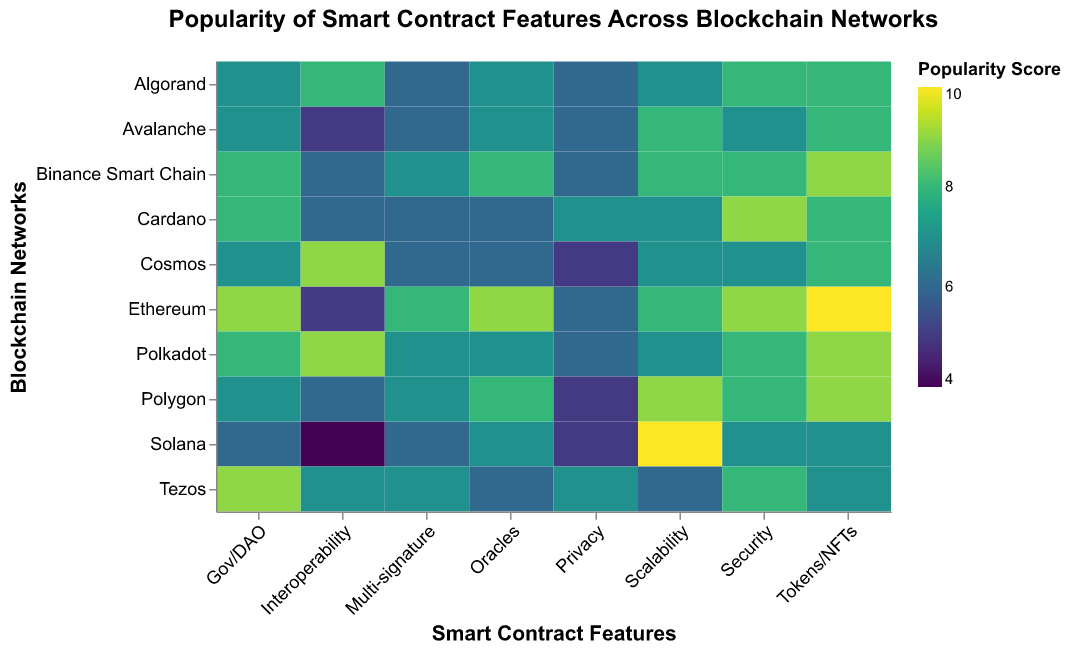What's the title of the figure? The title of the figure is prominently located at the top, which describes the general content of the visualization.
Answer: Popularity of Smart Contract Features Across Blockchain Networks Which blockchain network scores the highest for Scalability? Look at the color scale for Scalability. The darkest/vibrant color corresponds to the highest score.
Answer: Solana What is the average popularity score for Privacy across all blockchain networks? Extract the scores for Privacy from all networks: Ethereum (6), Binance Smart Chain (6), Polkadot (6), Solana (5), Cardano (7), Avalanche (6), Tezos (7), Polygon (5), Algorand (6), Cosmos (5). Sum these scores: 6+6+6+5+7+6+7+5+6+5 = 59. Divide by the number of networks (10): 59/10 = 5.9
Answer: 5.9 Which feature is the least popular for Solana? Identify the feature with the lowest color intensity (pale color) for Solana.
Answer: Interoperability Between Ethereum and Binance Smart Chain, which network scores higher on Security and by how much? Look at the rows for Ethereum and Binance Smart Chain under the Security column. Note the scores: Ethereum (9) and Binance Smart Chain (8). Subtract the smaller score from the larger one: 9 - 8 = 1
Answer: Ethereum by 1 Which feature shows the highest variance in popularity scores across all networks? Note the range of values for all features across networks. Calculate the range for each feature and identify the one with the highest variance.
Answer: Interoperability If you were to choose a blockchain network with a balanced high score for Multi-signature and Security, which one would you choose? Identify the networks with high scores in both Multi-signature and Security. Binance Smart Chain scores (7) and (8), Polkadot scores (7) and (8). Both networks have the same combination of high scores for these features.
Answer: Binance Smart Chain or Polkadot How does Cardano's overall popularity for Tokens/NFTs compare to the highest score for that feature across all blockchain networks? Locate Cardano’s score for Tokens/NFTs (8) and identify the highest score in the column for Tokens/NFTs (Ethereum at 10). Compare both values: 8 out of 10.
Answer: Cardano scores 2 points lower Which blockchain network has the lowest average popularity score across all features? Calculate the average score for each network and identify the lowest. Sum the scores for each network and divide by the number of features, then compare.
Answer: Solana 